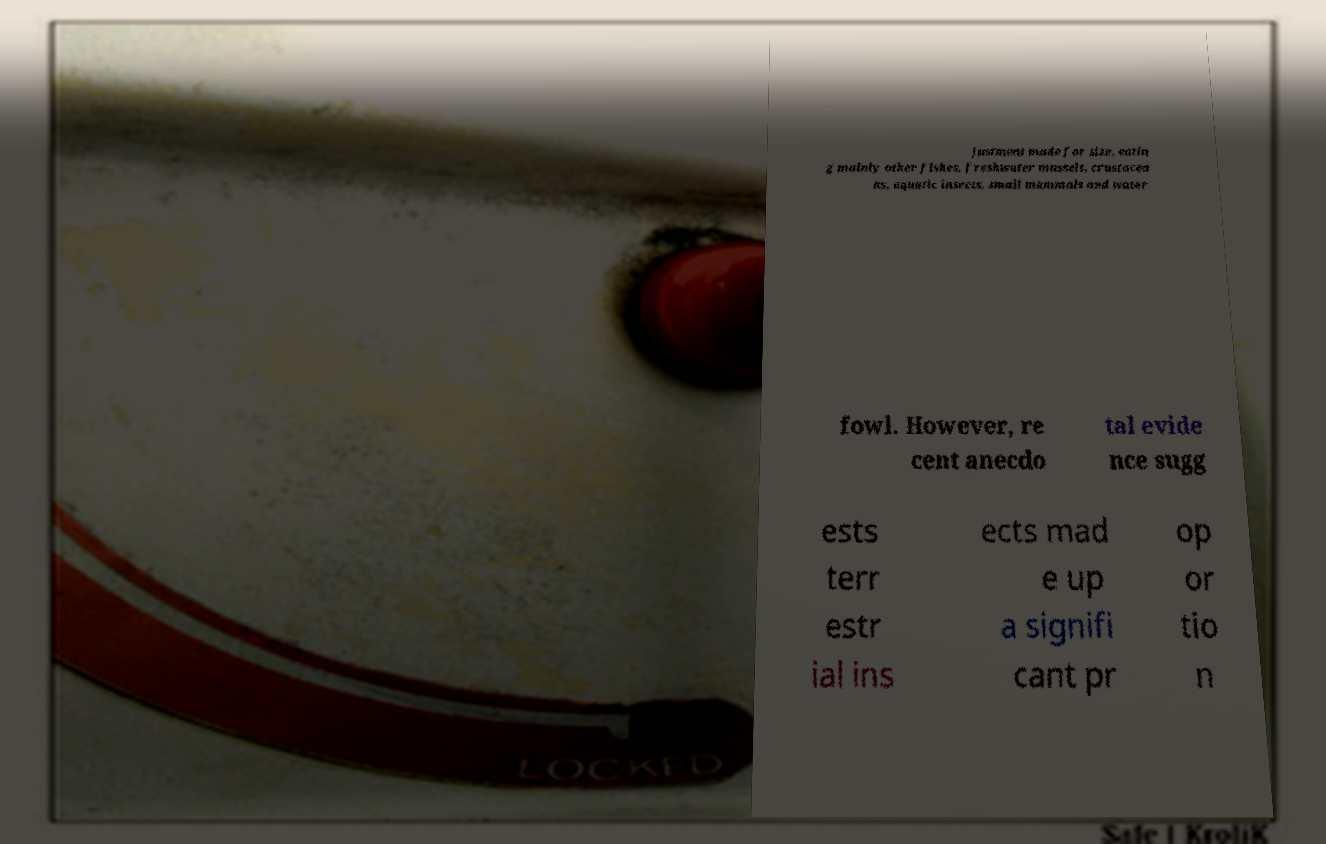There's text embedded in this image that I need extracted. Can you transcribe it verbatim? justment made for size, eatin g mainly other fishes, freshwater mussels, crustacea ns, aquatic insects, small mammals and water fowl. However, re cent anecdo tal evide nce sugg ests terr estr ial ins ects mad e up a signifi cant pr op or tio n 